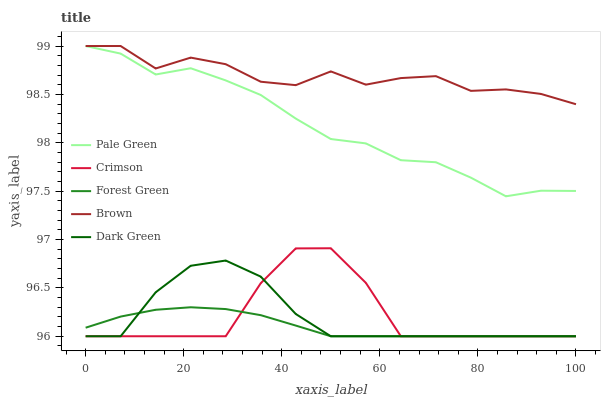Does Forest Green have the minimum area under the curve?
Answer yes or no. Yes. Does Brown have the maximum area under the curve?
Answer yes or no. Yes. Does Brown have the minimum area under the curve?
Answer yes or no. No. Does Forest Green have the maximum area under the curve?
Answer yes or no. No. Is Forest Green the smoothest?
Answer yes or no. Yes. Is Crimson the roughest?
Answer yes or no. Yes. Is Brown the smoothest?
Answer yes or no. No. Is Brown the roughest?
Answer yes or no. No. Does Crimson have the lowest value?
Answer yes or no. Yes. Does Brown have the lowest value?
Answer yes or no. No. Does Pale Green have the highest value?
Answer yes or no. Yes. Does Forest Green have the highest value?
Answer yes or no. No. Is Crimson less than Pale Green?
Answer yes or no. Yes. Is Brown greater than Dark Green?
Answer yes or no. Yes. Does Crimson intersect Dark Green?
Answer yes or no. Yes. Is Crimson less than Dark Green?
Answer yes or no. No. Is Crimson greater than Dark Green?
Answer yes or no. No. Does Crimson intersect Pale Green?
Answer yes or no. No. 